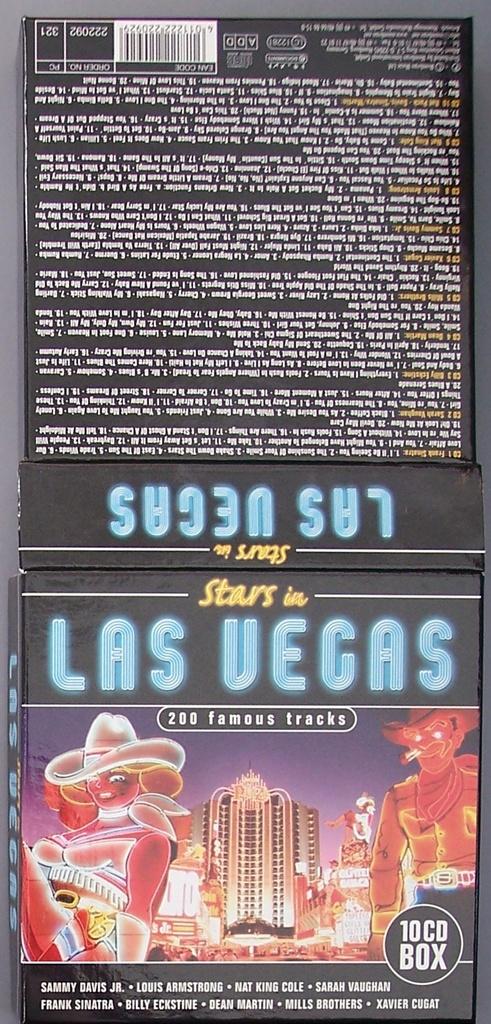What city is listed on this?
Offer a very short reply. Las vegas. How many cd's are in the box?
Your response must be concise. 10. 